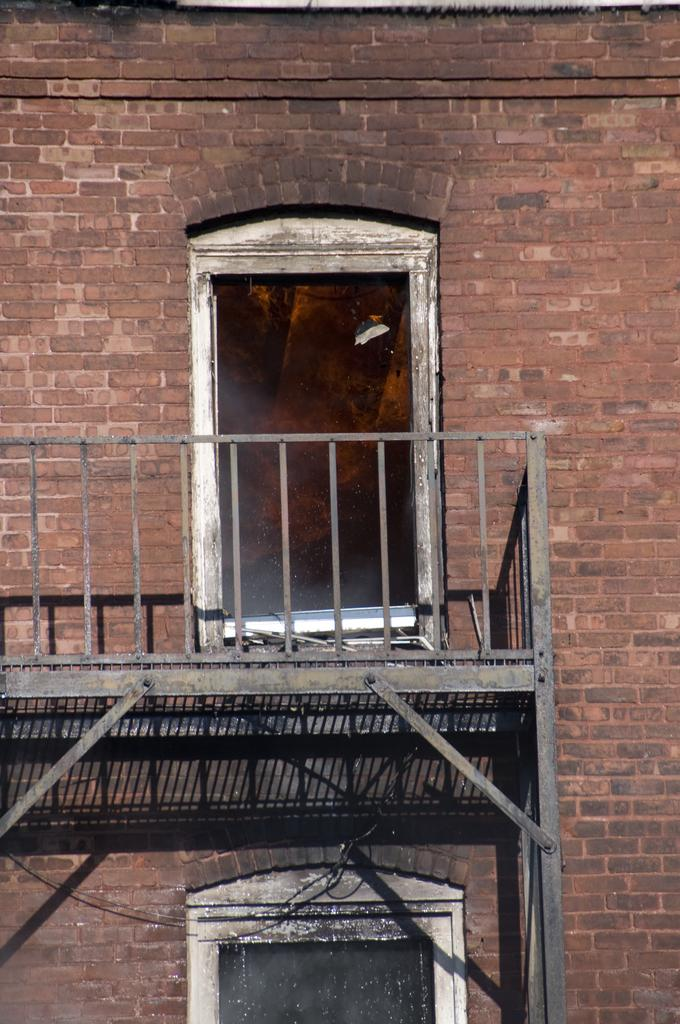What architectural feature is visible in the image? There is a window in the image. What type of barrier can be seen in the image? There is fencing in the image. What material is used to construct a structure in the image? There is a brick wall in the image. What type of insurance policy is being discussed in the image? There is no discussion of insurance policies in the image; it features a window, fencing, and a brick wall. How many spades are visible in the image? There are no spades present in the image. 